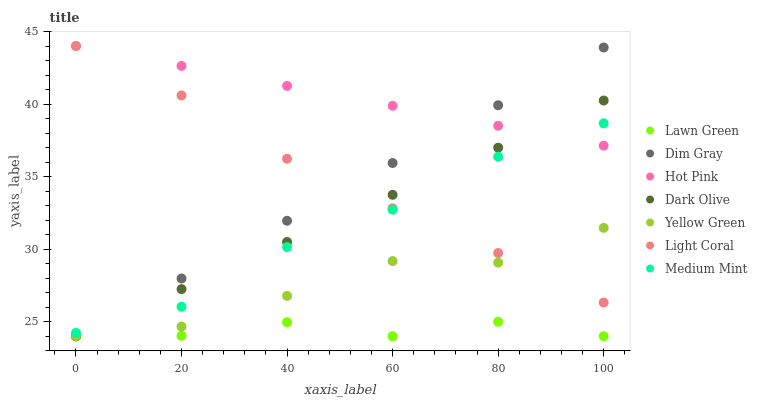Does Lawn Green have the minimum area under the curve?
Answer yes or no. Yes. Does Hot Pink have the maximum area under the curve?
Answer yes or no. Yes. Does Dim Gray have the minimum area under the curve?
Answer yes or no. No. Does Dim Gray have the maximum area under the curve?
Answer yes or no. No. Is Dim Gray the smoothest?
Answer yes or no. Yes. Is Lawn Green the roughest?
Answer yes or no. Yes. Is Lawn Green the smoothest?
Answer yes or no. No. Is Dim Gray the roughest?
Answer yes or no. No. Does Lawn Green have the lowest value?
Answer yes or no. Yes. Does Light Coral have the lowest value?
Answer yes or no. No. Does Hot Pink have the highest value?
Answer yes or no. Yes. Does Dim Gray have the highest value?
Answer yes or no. No. Is Yellow Green less than Hot Pink?
Answer yes or no. Yes. Is Hot Pink greater than Lawn Green?
Answer yes or no. Yes. Does Medium Mint intersect Light Coral?
Answer yes or no. Yes. Is Medium Mint less than Light Coral?
Answer yes or no. No. Is Medium Mint greater than Light Coral?
Answer yes or no. No. Does Yellow Green intersect Hot Pink?
Answer yes or no. No. 